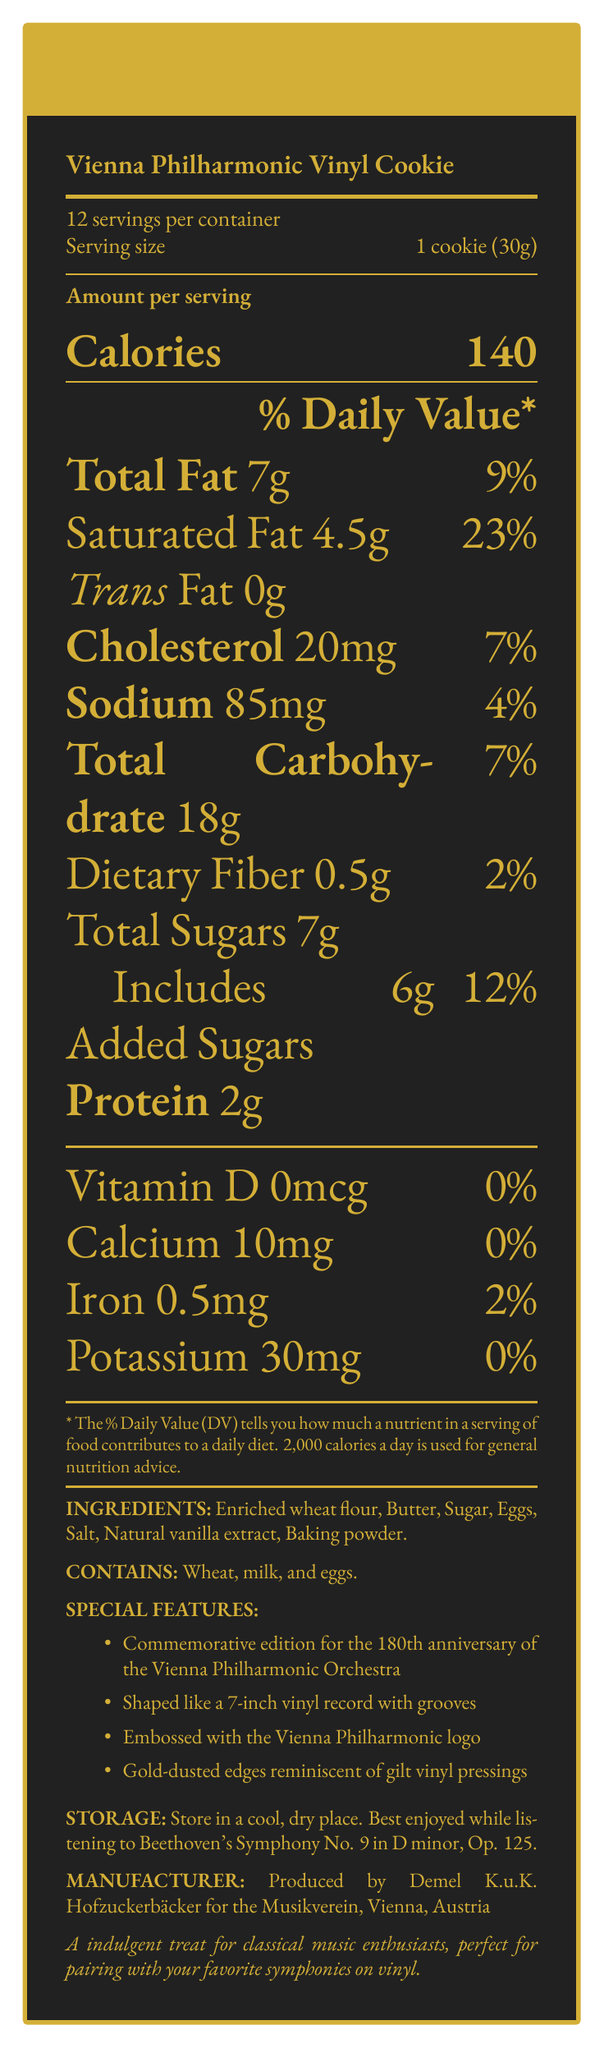What is the serving size of the Vienna Philharmonic Vinyl Cookie? The serving size is mentioned as "1 cookie (30g)" in the document.
Answer: 1 cookie (30g) How many servings are there per container? The document states "12 servings per container".
Answer: 12 How many calories are there per serving? The document lists "Calories 140" per serving.
Answer: 140 What is the total fat content per serving? The total fat content is listed as "7g" next to "Total Fat".
Answer: 7g What is the suggested storage instruction for the cookie? The document mentions "Store in a cool, dry place" under storage instructions.
Answer: Store in a cool, dry place What is the percent daily value of saturated fat per serving? The document specifies "Saturated Fat 4.5g" and shows its daily value as "23%".
Answer: 23% What ingredient gives the cookie its unique flavor? The ingredient list includes "Natural vanilla extract" which contributes to the flavor.
Answer: Natural vanilla extract What special feature of the cookie commemorates the 180th anniversary of the Vienna Philharmonic Orchestra? This special feature is listed in the document.
Answer: Commemorative edition for the 180th anniversary of the Vienna Philharmonic Orchestra Does the cookie contain trans fat? The document clearly states "Trans Fat 0g".
Answer: No Summarize the main points of the document. The document provides comprehensive details about the Vienna Philharmonic Vinyl Cookie, including nutritional facts, ingredients, allergens, special features, storage instructions, and the manufacturer.
Answer: The document is a nutrition facts label for the Vienna Philharmonic Vinyl Cookie, a commemorative shortbread cookie celebrating the 180th anniversary of the Vienna Philharmonic Orchestra. It details the nutritional information per serving, including calories, total fat, and sugar content, as well as listing the ingredients and allergens. Special features such as the vinyl shape and gold-dusted edges are also highlighted, along with storage instructions and manufacturer information. What is the total cholesterol content per serving? The document lists "Cholesterol 20mg" in the nutritional breakdown.
Answer: 20mg What company produces the Vienna Philharmonic Vinyl Cookie? This information is provided under the manufacturer information section.
Answer: Demel K.u.K. Hofzuckerbäcker for the Musikverein, Vienna, Austria Is there any vitamin D in the Vienna Philharmonic Vinyl Cookie? The document shows "Vitamin D 0mcg" and "0%" daily value for vitamin D.
Answer: No How should the Vienna Philharmonic Vinyl Cookie be best enjoyed? The document suggests enjoying the cookie while listening to this specific symphony.
Answer: While listening to Beethoven's Symphony No. 9 in D minor, Op. 125 What is the calcium percent daily value per serving of the cookie? The document indicates "Calcium 10mg" and "0%" daily value for calcium.
Answer: 0% How much dietary fiber is in one serving? The document lists "Dietary Fiber 0.5g".
Answer: 0.5g What is the function of baking powder in the cookie? The specific function or role of baking powder is not detailed in the document, only that it is an ingredient.
Answer: Cannot be determined 